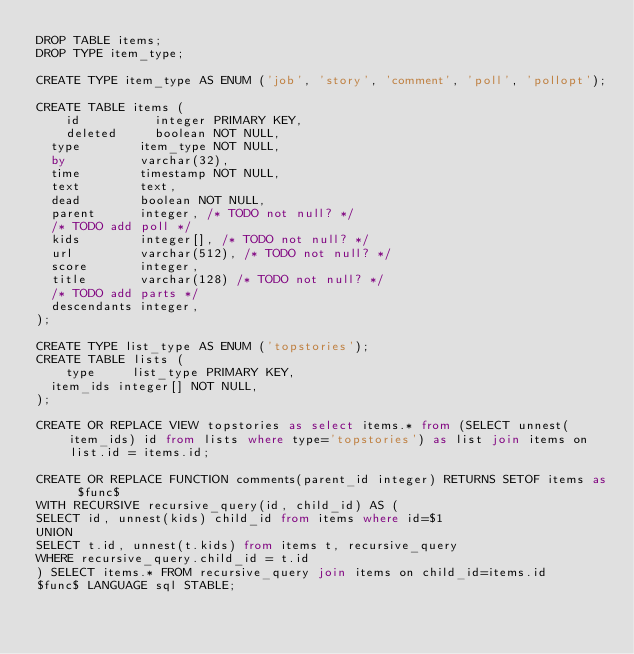<code> <loc_0><loc_0><loc_500><loc_500><_SQL_>DROP TABLE items;
DROP TYPE item_type;

CREATE TYPE item_type AS ENUM ('job', 'story', 'comment', 'poll', 'pollopt');

CREATE TABLE items (
	id          integer PRIMARY KEY,
	deleted     boolean NOT NULL,
  type        item_type NOT NULL,
  by          varchar(32),
  time        timestamp NOT NULL,
  text        text,
  dead        boolean NOT NULL,
  parent      integer, /* TODO not null? */
  /* TODO add poll */
  kids        integer[], /* TODO not null? */
  url         varchar(512), /* TODO not null? */
  score       integer,
  title       varchar(128) /* TODO not null? */
  /* TODO add parts */
  descendants integer,
);

CREATE TYPE list_type AS ENUM ('topstories');
CREATE TABLE lists (
	type     list_type PRIMARY KEY,
  item_ids integer[] NOT NULL,
);

CREATE OR REPLACE VIEW topstories as select items.* from (SELECT unnest(item_ids) id from lists where type='topstories') as list join items on list.id = items.id;

CREATE OR REPLACE FUNCTION comments(parent_id integer) RETURNS SETOF items as $func$ 
WITH RECURSIVE recursive_query(id, child_id) AS (
SELECT id, unnest(kids) child_id from items where id=$1
UNION
SELECT t.id, unnest(t.kids) from items t, recursive_query
WHERE recursive_query.child_id = t.id
) SELECT items.* FROM recursive_query join items on child_id=items.id
$func$ LANGUAGE sql STABLE;
</code> 